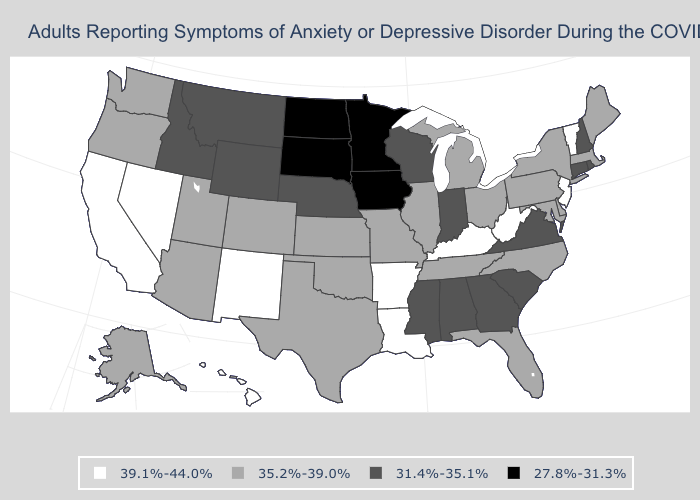What is the value of Oklahoma?
Keep it brief. 35.2%-39.0%. What is the highest value in the USA?
Short answer required. 39.1%-44.0%. Which states have the lowest value in the USA?
Answer briefly. Iowa, Minnesota, North Dakota, South Dakota. What is the lowest value in states that border Ohio?
Keep it brief. 31.4%-35.1%. Which states have the lowest value in the South?
Be succinct. Alabama, Georgia, Mississippi, South Carolina, Virginia. Does the first symbol in the legend represent the smallest category?
Concise answer only. No. Name the states that have a value in the range 39.1%-44.0%?
Concise answer only. Arkansas, California, Hawaii, Kentucky, Louisiana, Nevada, New Jersey, New Mexico, Vermont, West Virginia. Does Virginia have the same value as Hawaii?
Write a very short answer. No. Name the states that have a value in the range 35.2%-39.0%?
Short answer required. Alaska, Arizona, Colorado, Delaware, Florida, Illinois, Kansas, Maine, Maryland, Massachusetts, Michigan, Missouri, New York, North Carolina, Ohio, Oklahoma, Oregon, Pennsylvania, Tennessee, Texas, Utah, Washington. What is the value of Florida?
Give a very brief answer. 35.2%-39.0%. Is the legend a continuous bar?
Concise answer only. No. What is the highest value in the MidWest ?
Short answer required. 35.2%-39.0%. What is the lowest value in the South?
Keep it brief. 31.4%-35.1%. Among the states that border South Dakota , which have the lowest value?
Concise answer only. Iowa, Minnesota, North Dakota. Which states have the highest value in the USA?
Give a very brief answer. Arkansas, California, Hawaii, Kentucky, Louisiana, Nevada, New Jersey, New Mexico, Vermont, West Virginia. 